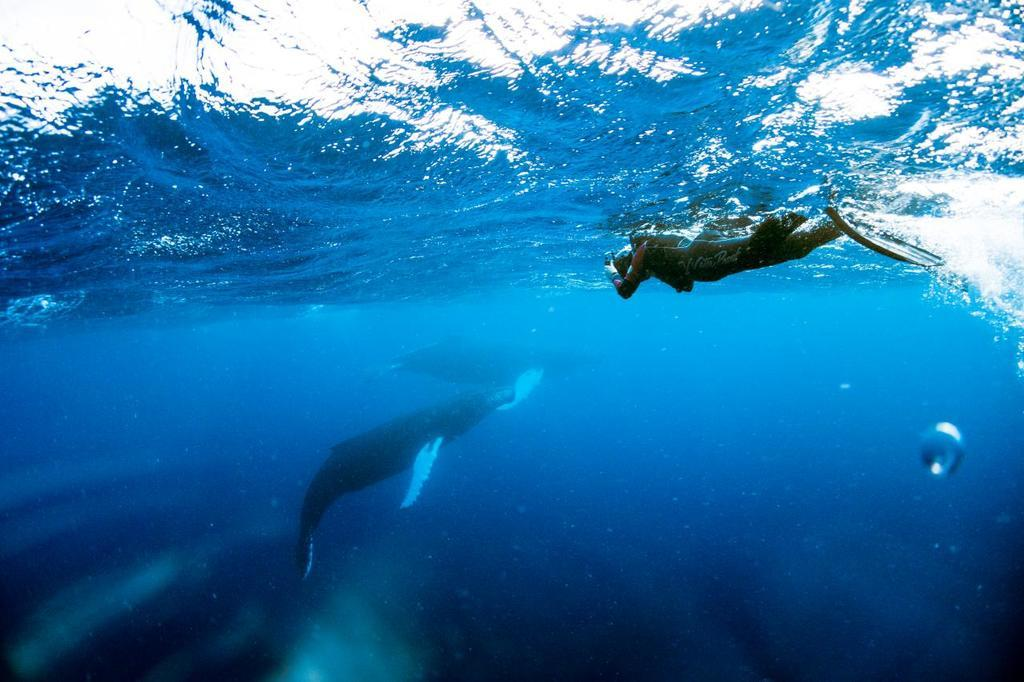What type of animals can be seen in the image? There are aquatic animals in the image. What is the person in the image doing? The person is in the water. What is the person holding in the image? The person is holding an object. What type of underwear is the boy wearing in the image? There is no boy present in the image, and therefore no information about underwear can be provided. 